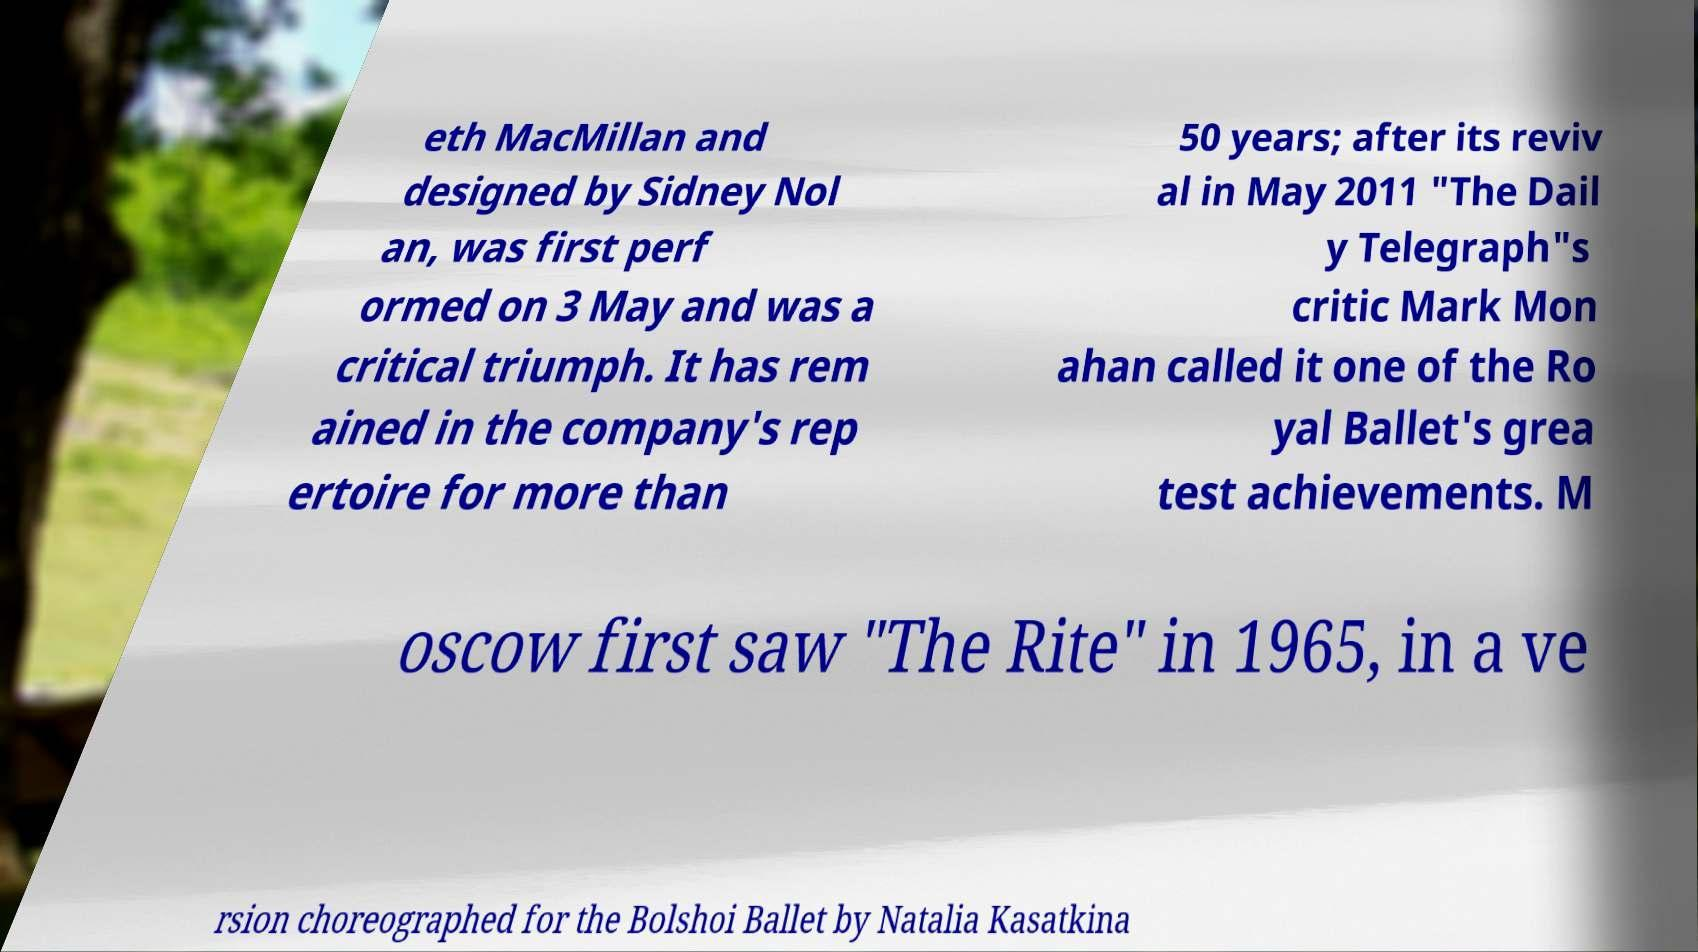What messages or text are displayed in this image? I need them in a readable, typed format. eth MacMillan and designed by Sidney Nol an, was first perf ormed on 3 May and was a critical triumph. It has rem ained in the company's rep ertoire for more than 50 years; after its reviv al in May 2011 "The Dail y Telegraph"s critic Mark Mon ahan called it one of the Ro yal Ballet's grea test achievements. M oscow first saw "The Rite" in 1965, in a ve rsion choreographed for the Bolshoi Ballet by Natalia Kasatkina 